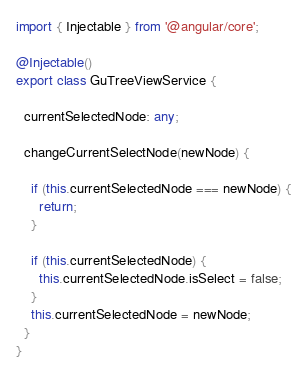Convert code to text. <code><loc_0><loc_0><loc_500><loc_500><_TypeScript_>import { Injectable } from '@angular/core';

@Injectable()
export class GuTreeViewService {

  currentSelectedNode: any;

  changeCurrentSelectNode(newNode) {

    if (this.currentSelectedNode === newNode) {
      return;
    }

    if (this.currentSelectedNode) {
      this.currentSelectedNode.isSelect = false;
    }
    this.currentSelectedNode = newNode;
  }
}
</code> 